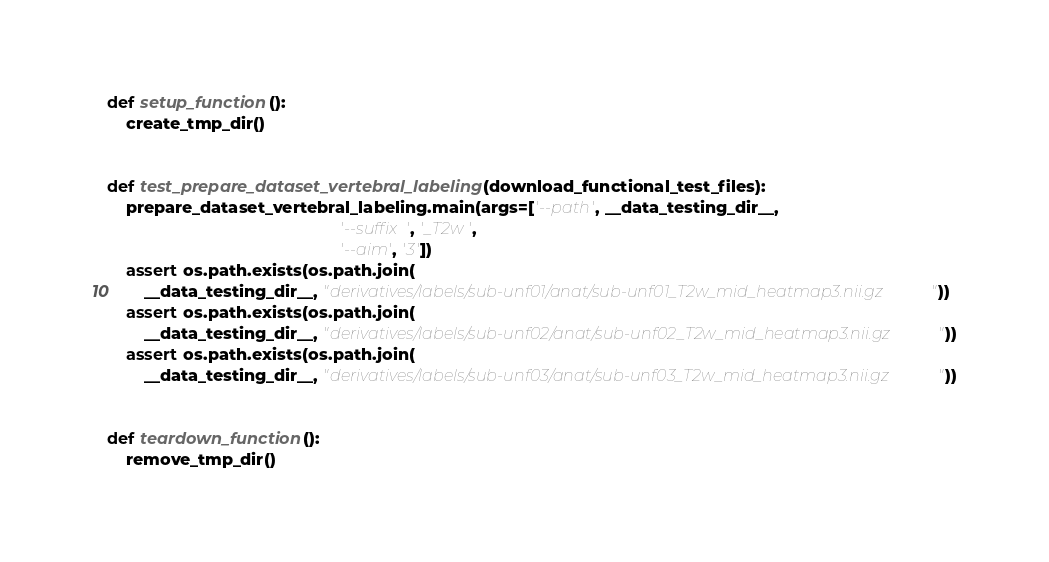Convert code to text. <code><loc_0><loc_0><loc_500><loc_500><_Python_>

def setup_function():
    create_tmp_dir()


def test_prepare_dataset_vertebral_labeling(download_functional_test_files):
    prepare_dataset_vertebral_labeling.main(args=['--path', __data_testing_dir__,
                                                  '--suffix', '_T2w',
                                                  '--aim', '3'])
    assert os.path.exists(os.path.join(
        __data_testing_dir__, "derivatives/labels/sub-unf01/anat/sub-unf01_T2w_mid_heatmap3.nii.gz"))
    assert os.path.exists(os.path.join(
        __data_testing_dir__, "derivatives/labels/sub-unf02/anat/sub-unf02_T2w_mid_heatmap3.nii.gz"))
    assert os.path.exists(os.path.join(
        __data_testing_dir__, "derivatives/labels/sub-unf03/anat/sub-unf03_T2w_mid_heatmap3.nii.gz"))


def teardown_function():
    remove_tmp_dir()
</code> 